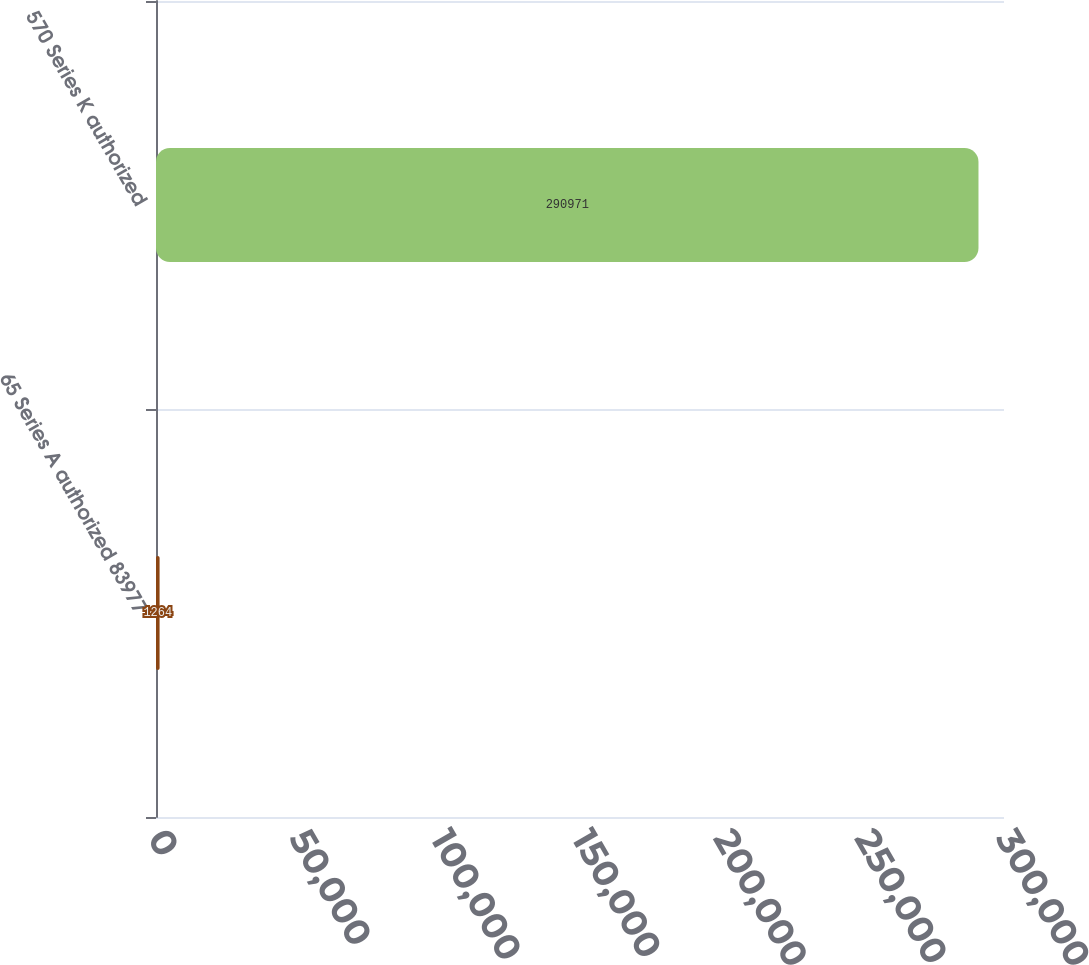Convert chart. <chart><loc_0><loc_0><loc_500><loc_500><bar_chart><fcel>65 Series A authorized 83977<fcel>570 Series K authorized<nl><fcel>1264<fcel>290971<nl></chart> 